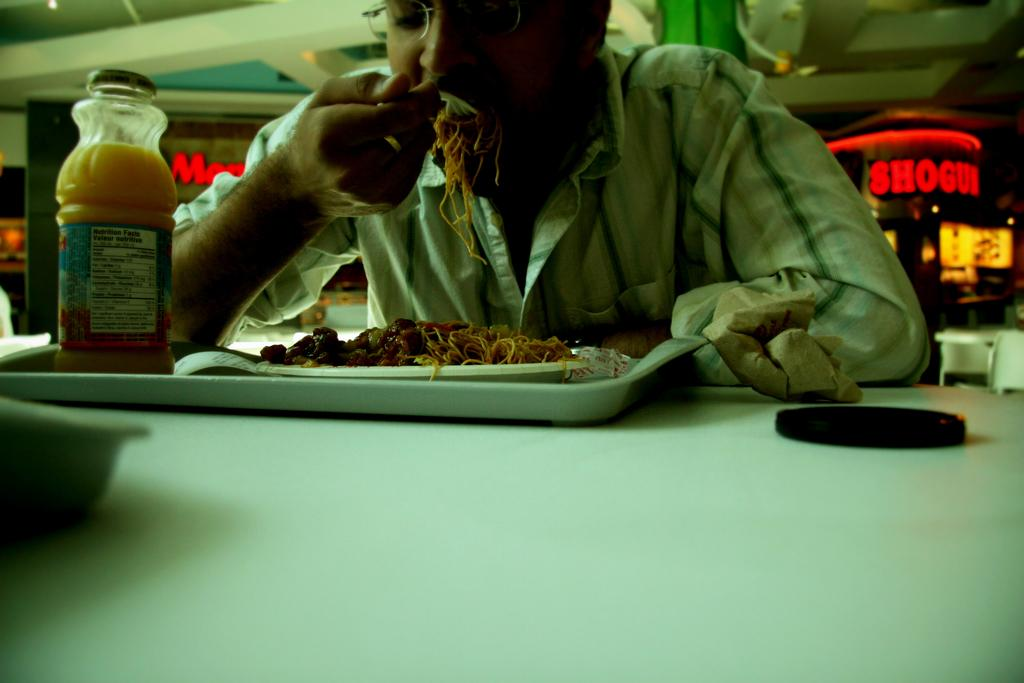<image>
Render a clear and concise summary of the photo. Among the restaurants in the food court was Shogui. 